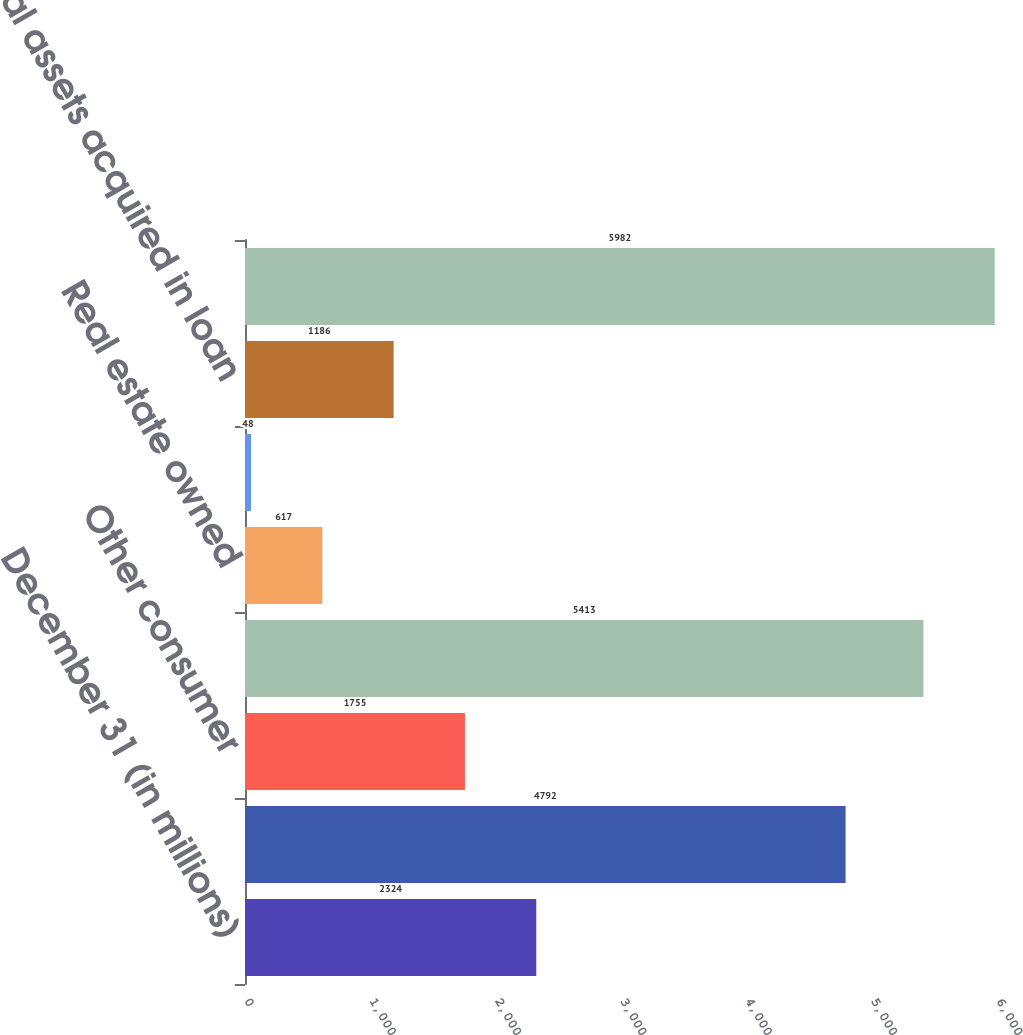Convert chart. <chart><loc_0><loc_0><loc_500><loc_500><bar_chart><fcel>December 31 (in millions)<fcel>Residential real estate<fcel>Other consumer<fcel>Total nonaccrual loans<fcel>Real estate owned<fcel>Other<fcel>Total assets acquired in loan<fcel>Total nonperforming assets<nl><fcel>2324<fcel>4792<fcel>1755<fcel>5413<fcel>617<fcel>48<fcel>1186<fcel>5982<nl></chart> 